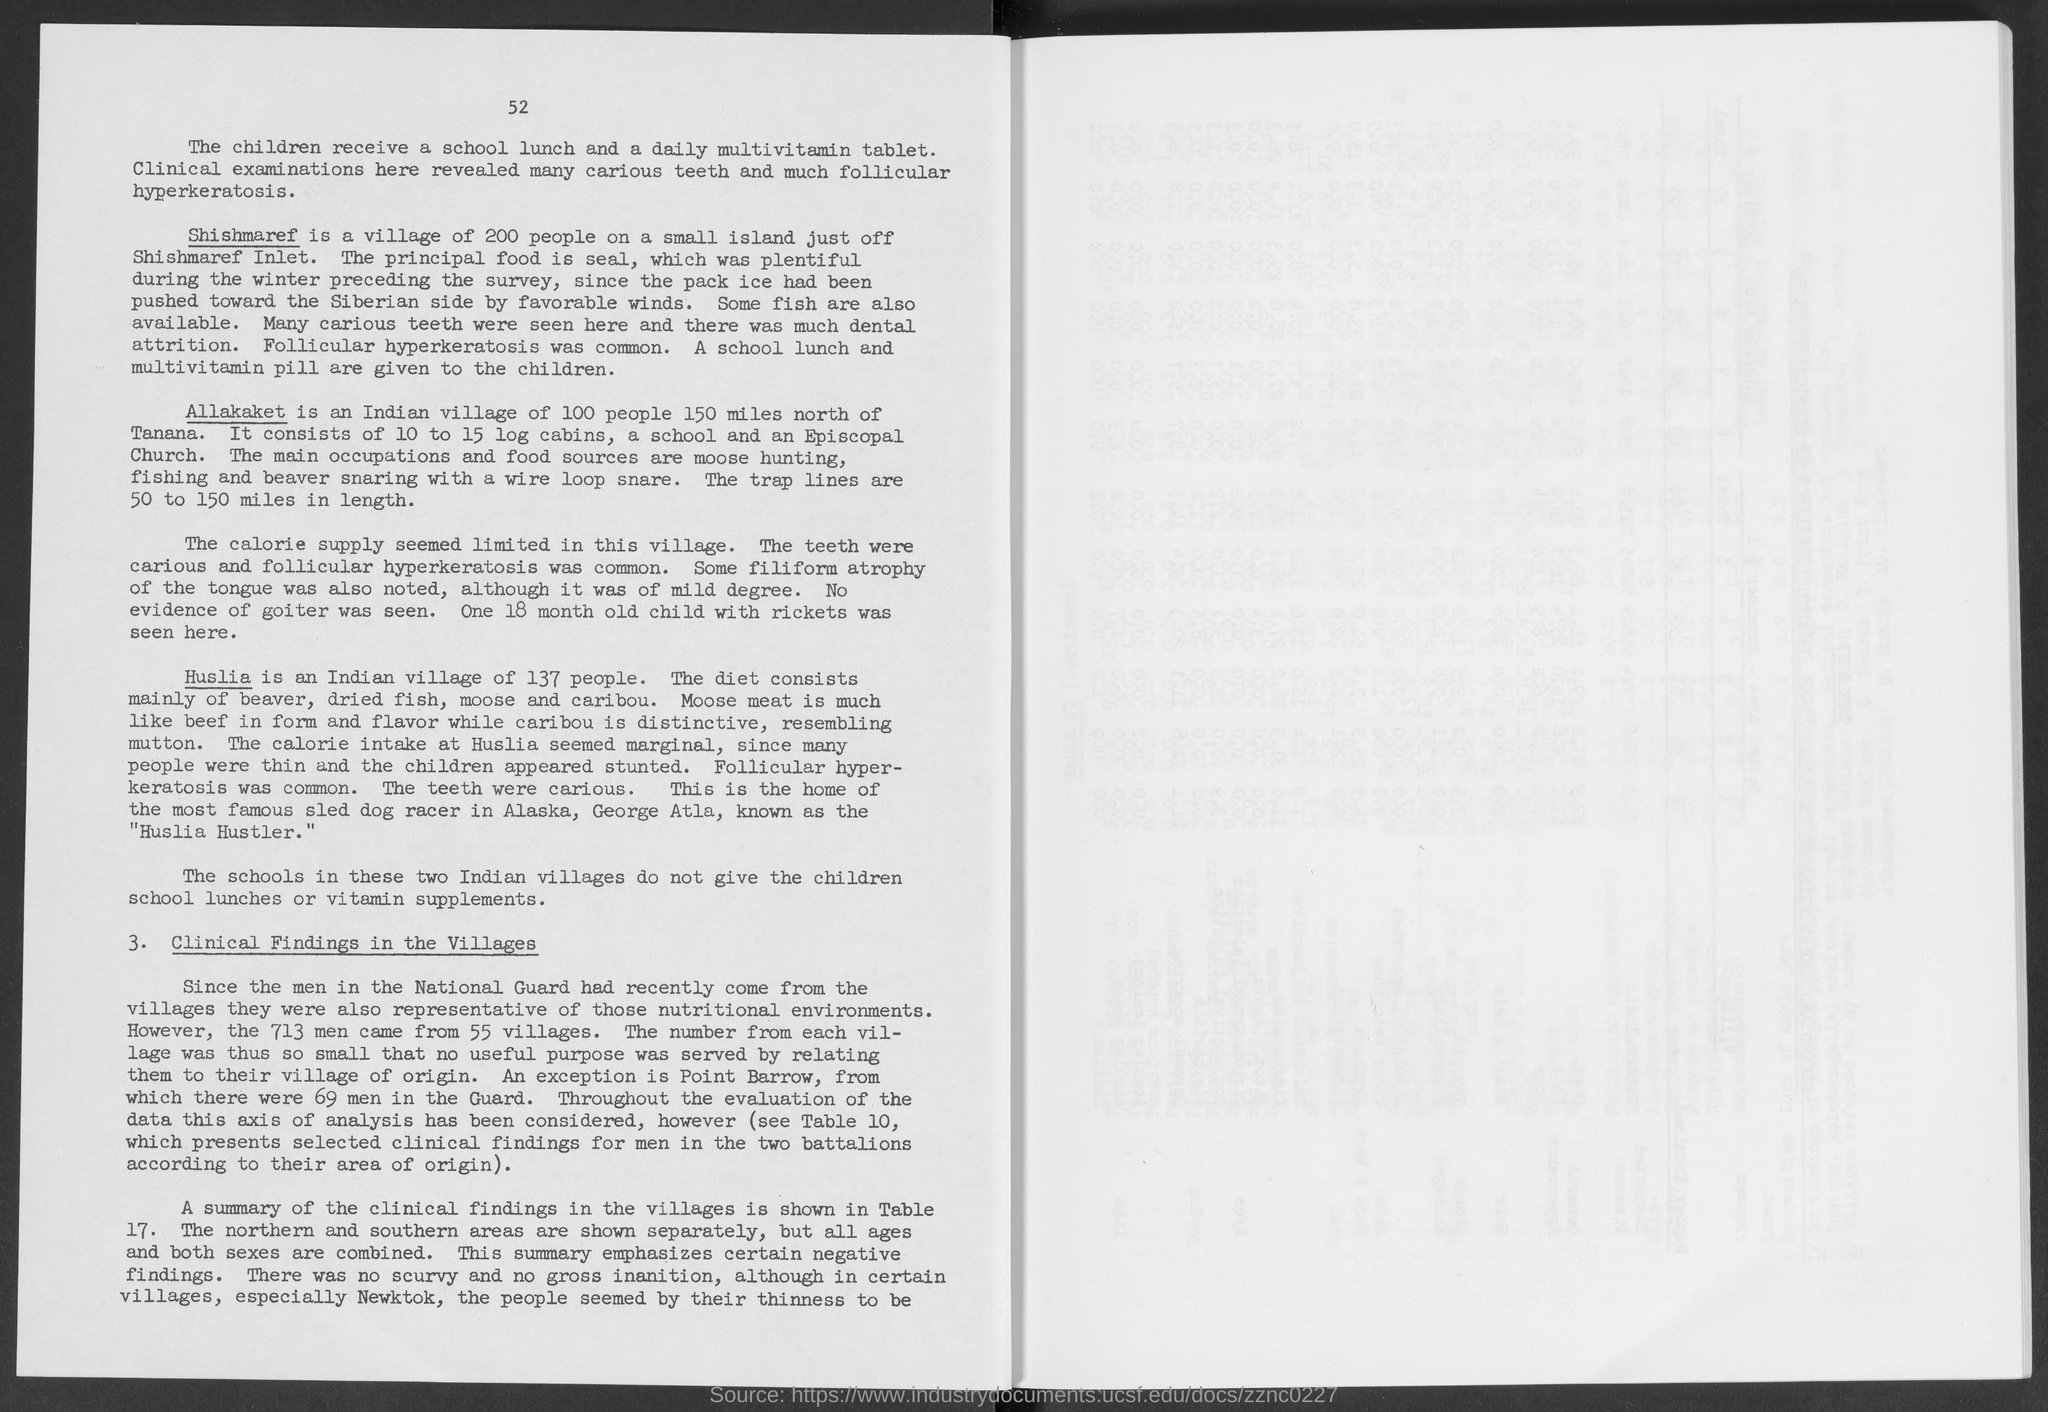Mention a couple of crucial points in this snapshot. Allakaket, an Indian village located 150 miles north of Tanana, is home to approximately 100 people. Huslia is an Indian village with a population of 137 people. Shishmaref, a village of 200 people located on a small island just off Shishmaref Inlet, is a desirable destination for those seeking a peaceful and secluded retreat. 